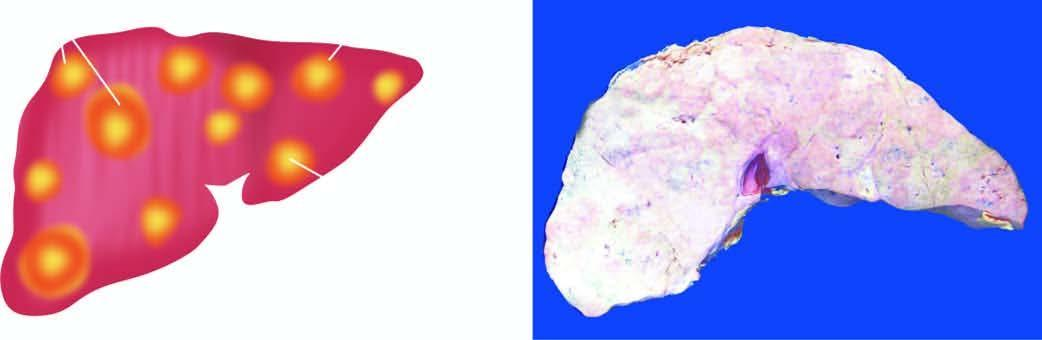do characteristic features include multiple, variable-sized, nodular masses, often under the capsule, producing umbilication on the surface?
Answer the question using a single word or phrase. Yes 